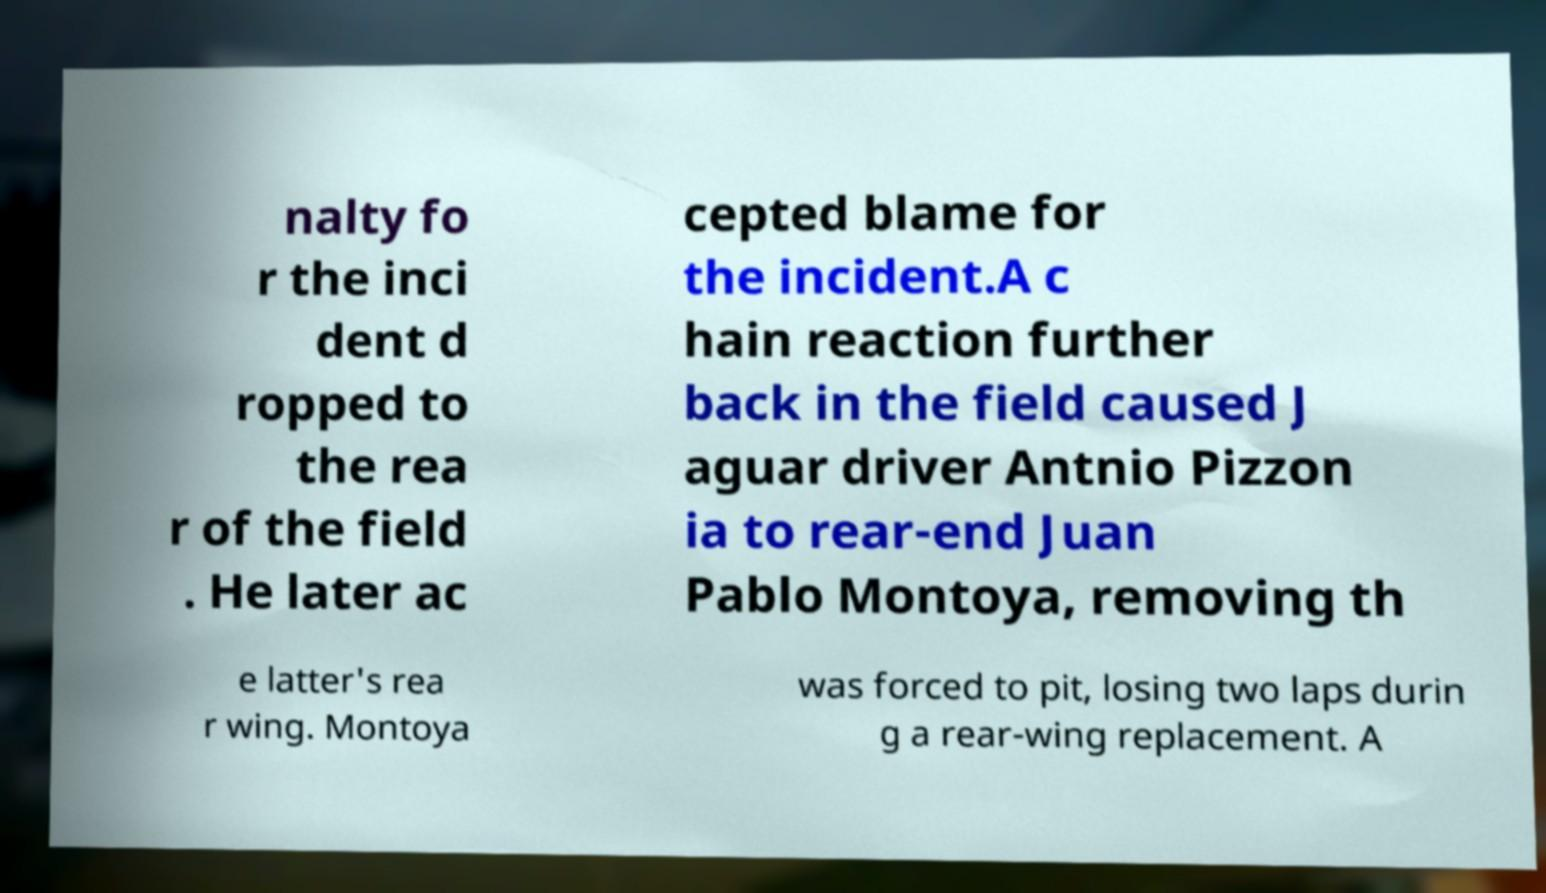Could you assist in decoding the text presented in this image and type it out clearly? nalty fo r the inci dent d ropped to the rea r of the field . He later ac cepted blame for the incident.A c hain reaction further back in the field caused J aguar driver Antnio Pizzon ia to rear-end Juan Pablo Montoya, removing th e latter's rea r wing. Montoya was forced to pit, losing two laps durin g a rear-wing replacement. A 